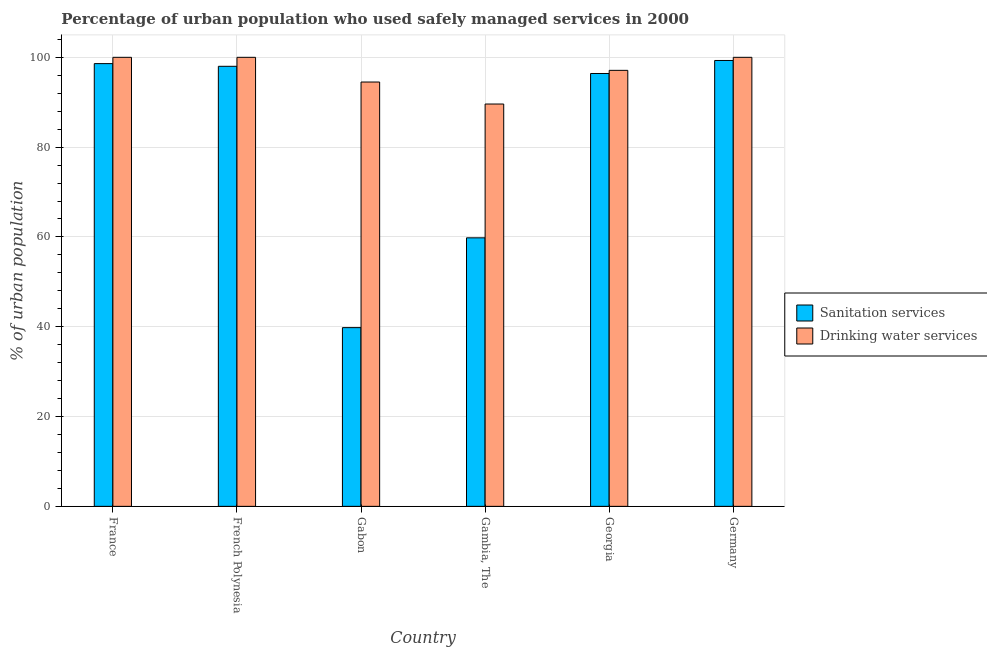How many different coloured bars are there?
Your answer should be compact. 2. How many groups of bars are there?
Your response must be concise. 6. How many bars are there on the 3rd tick from the left?
Give a very brief answer. 2. What is the label of the 6th group of bars from the left?
Give a very brief answer. Germany. In how many cases, is the number of bars for a given country not equal to the number of legend labels?
Keep it short and to the point. 0. What is the percentage of urban population who used sanitation services in Georgia?
Your response must be concise. 96.4. Across all countries, what is the maximum percentage of urban population who used sanitation services?
Offer a very short reply. 99.3. Across all countries, what is the minimum percentage of urban population who used drinking water services?
Give a very brief answer. 89.6. In which country was the percentage of urban population who used drinking water services minimum?
Your answer should be compact. Gambia, The. What is the total percentage of urban population who used sanitation services in the graph?
Offer a terse response. 491.9. What is the difference between the percentage of urban population who used sanitation services in Gabon and that in Germany?
Offer a terse response. -59.5. What is the difference between the percentage of urban population who used drinking water services in Gambia, The and the percentage of urban population who used sanitation services in Gabon?
Keep it short and to the point. 49.8. What is the average percentage of urban population who used drinking water services per country?
Provide a short and direct response. 96.87. What is the difference between the percentage of urban population who used sanitation services and percentage of urban population who used drinking water services in France?
Make the answer very short. -1.4. In how many countries, is the percentage of urban population who used drinking water services greater than 12 %?
Make the answer very short. 6. What is the ratio of the percentage of urban population who used sanitation services in French Polynesia to that in Georgia?
Ensure brevity in your answer.  1.02. Is the percentage of urban population who used drinking water services in France less than that in Georgia?
Your answer should be compact. No. What is the difference between the highest and the second highest percentage of urban population who used sanitation services?
Provide a succinct answer. 0.7. What is the difference between the highest and the lowest percentage of urban population who used drinking water services?
Offer a very short reply. 10.4. In how many countries, is the percentage of urban population who used drinking water services greater than the average percentage of urban population who used drinking water services taken over all countries?
Offer a terse response. 4. Is the sum of the percentage of urban population who used drinking water services in Gambia, The and Germany greater than the maximum percentage of urban population who used sanitation services across all countries?
Offer a very short reply. Yes. What does the 2nd bar from the left in Georgia represents?
Make the answer very short. Drinking water services. What does the 2nd bar from the right in Georgia represents?
Provide a short and direct response. Sanitation services. How many bars are there?
Provide a succinct answer. 12. Are all the bars in the graph horizontal?
Your answer should be very brief. No. Does the graph contain any zero values?
Provide a short and direct response. No. Does the graph contain grids?
Provide a short and direct response. Yes. How are the legend labels stacked?
Provide a succinct answer. Vertical. What is the title of the graph?
Your answer should be very brief. Percentage of urban population who used safely managed services in 2000. Does "Gasoline" appear as one of the legend labels in the graph?
Offer a very short reply. No. What is the label or title of the Y-axis?
Offer a very short reply. % of urban population. What is the % of urban population of Sanitation services in France?
Your response must be concise. 98.6. What is the % of urban population in Sanitation services in French Polynesia?
Ensure brevity in your answer.  98. What is the % of urban population of Drinking water services in French Polynesia?
Keep it short and to the point. 100. What is the % of urban population in Sanitation services in Gabon?
Provide a succinct answer. 39.8. What is the % of urban population in Drinking water services in Gabon?
Ensure brevity in your answer.  94.5. What is the % of urban population in Sanitation services in Gambia, The?
Offer a very short reply. 59.8. What is the % of urban population in Drinking water services in Gambia, The?
Keep it short and to the point. 89.6. What is the % of urban population of Sanitation services in Georgia?
Keep it short and to the point. 96.4. What is the % of urban population in Drinking water services in Georgia?
Make the answer very short. 97.1. What is the % of urban population of Sanitation services in Germany?
Offer a very short reply. 99.3. What is the % of urban population in Drinking water services in Germany?
Ensure brevity in your answer.  100. Across all countries, what is the maximum % of urban population in Sanitation services?
Ensure brevity in your answer.  99.3. Across all countries, what is the maximum % of urban population of Drinking water services?
Offer a very short reply. 100. Across all countries, what is the minimum % of urban population in Sanitation services?
Your response must be concise. 39.8. Across all countries, what is the minimum % of urban population of Drinking water services?
Your answer should be compact. 89.6. What is the total % of urban population in Sanitation services in the graph?
Give a very brief answer. 491.9. What is the total % of urban population of Drinking water services in the graph?
Offer a very short reply. 581.2. What is the difference between the % of urban population of Drinking water services in France and that in French Polynesia?
Offer a terse response. 0. What is the difference between the % of urban population in Sanitation services in France and that in Gabon?
Keep it short and to the point. 58.8. What is the difference between the % of urban population in Drinking water services in France and that in Gabon?
Provide a succinct answer. 5.5. What is the difference between the % of urban population of Sanitation services in France and that in Gambia, The?
Give a very brief answer. 38.8. What is the difference between the % of urban population of Sanitation services in France and that in Georgia?
Your answer should be very brief. 2.2. What is the difference between the % of urban population in Drinking water services in France and that in Georgia?
Give a very brief answer. 2.9. What is the difference between the % of urban population in Sanitation services in French Polynesia and that in Gabon?
Offer a terse response. 58.2. What is the difference between the % of urban population of Drinking water services in French Polynesia and that in Gabon?
Your answer should be compact. 5.5. What is the difference between the % of urban population of Sanitation services in French Polynesia and that in Gambia, The?
Your response must be concise. 38.2. What is the difference between the % of urban population of Drinking water services in French Polynesia and that in Georgia?
Provide a succinct answer. 2.9. What is the difference between the % of urban population in Sanitation services in French Polynesia and that in Germany?
Keep it short and to the point. -1.3. What is the difference between the % of urban population in Sanitation services in Gabon and that in Georgia?
Ensure brevity in your answer.  -56.6. What is the difference between the % of urban population of Sanitation services in Gabon and that in Germany?
Provide a succinct answer. -59.5. What is the difference between the % of urban population in Sanitation services in Gambia, The and that in Georgia?
Keep it short and to the point. -36.6. What is the difference between the % of urban population in Sanitation services in Gambia, The and that in Germany?
Offer a terse response. -39.5. What is the difference between the % of urban population of Sanitation services in Georgia and that in Germany?
Make the answer very short. -2.9. What is the difference between the % of urban population in Sanitation services in France and the % of urban population in Drinking water services in French Polynesia?
Offer a terse response. -1.4. What is the difference between the % of urban population of Sanitation services in France and the % of urban population of Drinking water services in Germany?
Your answer should be compact. -1.4. What is the difference between the % of urban population of Sanitation services in French Polynesia and the % of urban population of Drinking water services in Georgia?
Offer a terse response. 0.9. What is the difference between the % of urban population in Sanitation services in Gabon and the % of urban population in Drinking water services in Gambia, The?
Your response must be concise. -49.8. What is the difference between the % of urban population of Sanitation services in Gabon and the % of urban population of Drinking water services in Georgia?
Offer a very short reply. -57.3. What is the difference between the % of urban population of Sanitation services in Gabon and the % of urban population of Drinking water services in Germany?
Ensure brevity in your answer.  -60.2. What is the difference between the % of urban population in Sanitation services in Gambia, The and the % of urban population in Drinking water services in Georgia?
Make the answer very short. -37.3. What is the difference between the % of urban population in Sanitation services in Gambia, The and the % of urban population in Drinking water services in Germany?
Provide a short and direct response. -40.2. What is the average % of urban population in Sanitation services per country?
Give a very brief answer. 81.98. What is the average % of urban population in Drinking water services per country?
Offer a terse response. 96.87. What is the difference between the % of urban population in Sanitation services and % of urban population in Drinking water services in France?
Offer a terse response. -1.4. What is the difference between the % of urban population in Sanitation services and % of urban population in Drinking water services in French Polynesia?
Your answer should be very brief. -2. What is the difference between the % of urban population in Sanitation services and % of urban population in Drinking water services in Gabon?
Your answer should be very brief. -54.7. What is the difference between the % of urban population of Sanitation services and % of urban population of Drinking water services in Gambia, The?
Ensure brevity in your answer.  -29.8. What is the difference between the % of urban population of Sanitation services and % of urban population of Drinking water services in Georgia?
Offer a terse response. -0.7. What is the ratio of the % of urban population in Sanitation services in France to that in Gabon?
Provide a short and direct response. 2.48. What is the ratio of the % of urban population of Drinking water services in France to that in Gabon?
Provide a succinct answer. 1.06. What is the ratio of the % of urban population of Sanitation services in France to that in Gambia, The?
Keep it short and to the point. 1.65. What is the ratio of the % of urban population of Drinking water services in France to that in Gambia, The?
Give a very brief answer. 1.12. What is the ratio of the % of urban population of Sanitation services in France to that in Georgia?
Give a very brief answer. 1.02. What is the ratio of the % of urban population of Drinking water services in France to that in Georgia?
Make the answer very short. 1.03. What is the ratio of the % of urban population in Drinking water services in France to that in Germany?
Your answer should be very brief. 1. What is the ratio of the % of urban population in Sanitation services in French Polynesia to that in Gabon?
Your response must be concise. 2.46. What is the ratio of the % of urban population of Drinking water services in French Polynesia to that in Gabon?
Give a very brief answer. 1.06. What is the ratio of the % of urban population of Sanitation services in French Polynesia to that in Gambia, The?
Give a very brief answer. 1.64. What is the ratio of the % of urban population in Drinking water services in French Polynesia to that in Gambia, The?
Give a very brief answer. 1.12. What is the ratio of the % of urban population of Sanitation services in French Polynesia to that in Georgia?
Provide a succinct answer. 1.02. What is the ratio of the % of urban population in Drinking water services in French Polynesia to that in Georgia?
Ensure brevity in your answer.  1.03. What is the ratio of the % of urban population of Sanitation services in French Polynesia to that in Germany?
Ensure brevity in your answer.  0.99. What is the ratio of the % of urban population of Drinking water services in French Polynesia to that in Germany?
Your answer should be compact. 1. What is the ratio of the % of urban population in Sanitation services in Gabon to that in Gambia, The?
Make the answer very short. 0.67. What is the ratio of the % of urban population in Drinking water services in Gabon to that in Gambia, The?
Offer a very short reply. 1.05. What is the ratio of the % of urban population of Sanitation services in Gabon to that in Georgia?
Your answer should be very brief. 0.41. What is the ratio of the % of urban population in Drinking water services in Gabon to that in Georgia?
Offer a very short reply. 0.97. What is the ratio of the % of urban population of Sanitation services in Gabon to that in Germany?
Keep it short and to the point. 0.4. What is the ratio of the % of urban population in Drinking water services in Gabon to that in Germany?
Provide a short and direct response. 0.94. What is the ratio of the % of urban population in Sanitation services in Gambia, The to that in Georgia?
Provide a succinct answer. 0.62. What is the ratio of the % of urban population of Drinking water services in Gambia, The to that in Georgia?
Your answer should be compact. 0.92. What is the ratio of the % of urban population of Sanitation services in Gambia, The to that in Germany?
Offer a terse response. 0.6. What is the ratio of the % of urban population of Drinking water services in Gambia, The to that in Germany?
Offer a very short reply. 0.9. What is the ratio of the % of urban population in Sanitation services in Georgia to that in Germany?
Provide a succinct answer. 0.97. What is the ratio of the % of urban population in Drinking water services in Georgia to that in Germany?
Provide a succinct answer. 0.97. What is the difference between the highest and the second highest % of urban population in Drinking water services?
Provide a succinct answer. 0. What is the difference between the highest and the lowest % of urban population of Sanitation services?
Ensure brevity in your answer.  59.5. What is the difference between the highest and the lowest % of urban population in Drinking water services?
Your answer should be very brief. 10.4. 